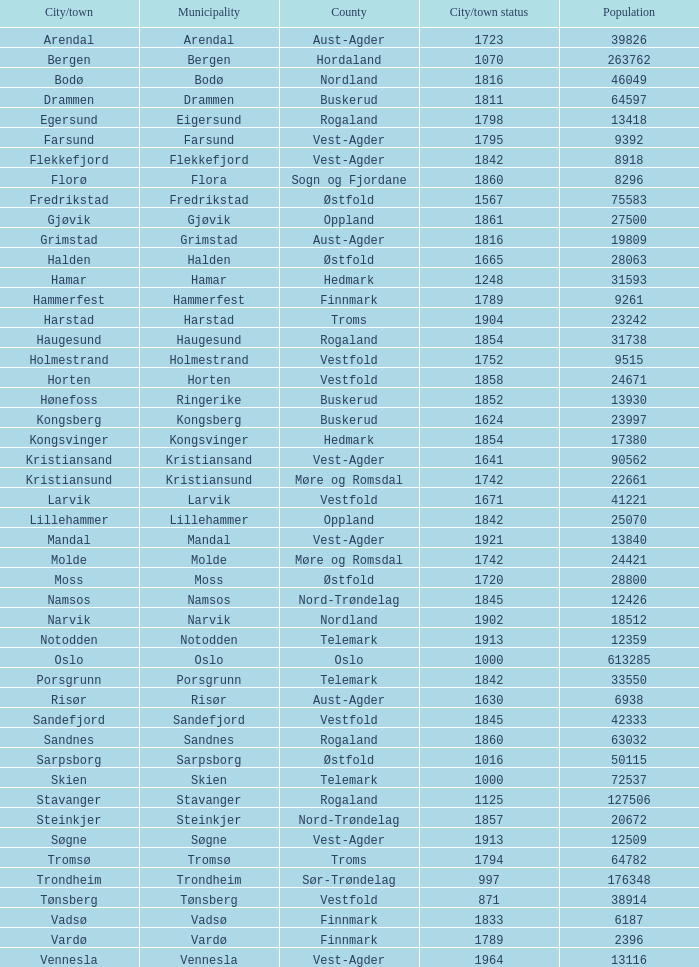Could you parse the entire table? {'header': ['City/town', 'Municipality', 'County', 'City/town status', 'Population'], 'rows': [['Arendal', 'Arendal', 'Aust-Agder', '1723', '39826'], ['Bergen', 'Bergen', 'Hordaland', '1070', '263762'], ['Bodø', 'Bodø', 'Nordland', '1816', '46049'], ['Drammen', 'Drammen', 'Buskerud', '1811', '64597'], ['Egersund', 'Eigersund', 'Rogaland', '1798', '13418'], ['Farsund', 'Farsund', 'Vest-Agder', '1795', '9392'], ['Flekkefjord', 'Flekkefjord', 'Vest-Agder', '1842', '8918'], ['Florø', 'Flora', 'Sogn og Fjordane', '1860', '8296'], ['Fredrikstad', 'Fredrikstad', 'Østfold', '1567', '75583'], ['Gjøvik', 'Gjøvik', 'Oppland', '1861', '27500'], ['Grimstad', 'Grimstad', 'Aust-Agder', '1816', '19809'], ['Halden', 'Halden', 'Østfold', '1665', '28063'], ['Hamar', 'Hamar', 'Hedmark', '1248', '31593'], ['Hammerfest', 'Hammerfest', 'Finnmark', '1789', '9261'], ['Harstad', 'Harstad', 'Troms', '1904', '23242'], ['Haugesund', 'Haugesund', 'Rogaland', '1854', '31738'], ['Holmestrand', 'Holmestrand', 'Vestfold', '1752', '9515'], ['Horten', 'Horten', 'Vestfold', '1858', '24671'], ['Hønefoss', 'Ringerike', 'Buskerud', '1852', '13930'], ['Kongsberg', 'Kongsberg', 'Buskerud', '1624', '23997'], ['Kongsvinger', 'Kongsvinger', 'Hedmark', '1854', '17380'], ['Kristiansand', 'Kristiansand', 'Vest-Agder', '1641', '90562'], ['Kristiansund', 'Kristiansund', 'Møre og Romsdal', '1742', '22661'], ['Larvik', 'Larvik', 'Vestfold', '1671', '41221'], ['Lillehammer', 'Lillehammer', 'Oppland', '1842', '25070'], ['Mandal', 'Mandal', 'Vest-Agder', '1921', '13840'], ['Molde', 'Molde', 'Møre og Romsdal', '1742', '24421'], ['Moss', 'Moss', 'Østfold', '1720', '28800'], ['Namsos', 'Namsos', 'Nord-Trøndelag', '1845', '12426'], ['Narvik', 'Narvik', 'Nordland', '1902', '18512'], ['Notodden', 'Notodden', 'Telemark', '1913', '12359'], ['Oslo', 'Oslo', 'Oslo', '1000', '613285'], ['Porsgrunn', 'Porsgrunn', 'Telemark', '1842', '33550'], ['Risør', 'Risør', 'Aust-Agder', '1630', '6938'], ['Sandefjord', 'Sandefjord', 'Vestfold', '1845', '42333'], ['Sandnes', 'Sandnes', 'Rogaland', '1860', '63032'], ['Sarpsborg', 'Sarpsborg', 'Østfold', '1016', '50115'], ['Skien', 'Skien', 'Telemark', '1000', '72537'], ['Stavanger', 'Stavanger', 'Rogaland', '1125', '127506'], ['Steinkjer', 'Steinkjer', 'Nord-Trøndelag', '1857', '20672'], ['Søgne', 'Søgne', 'Vest-Agder', '1913', '12509'], ['Tromsø', 'Tromsø', 'Troms', '1794', '64782'], ['Trondheim', 'Trondheim', 'Sør-Trøndelag', '997', '176348'], ['Tønsberg', 'Tønsberg', 'Vestfold', '871', '38914'], ['Vadsø', 'Vadsø', 'Finnmark', '1833', '6187'], ['Vardø', 'Vardø', 'Finnmark', '1789', '2396'], ['Vennesla', 'Vennesla', 'Vest-Agder', '1964', '13116']]} What is the overall population in the city/town of arendal? 1.0. 